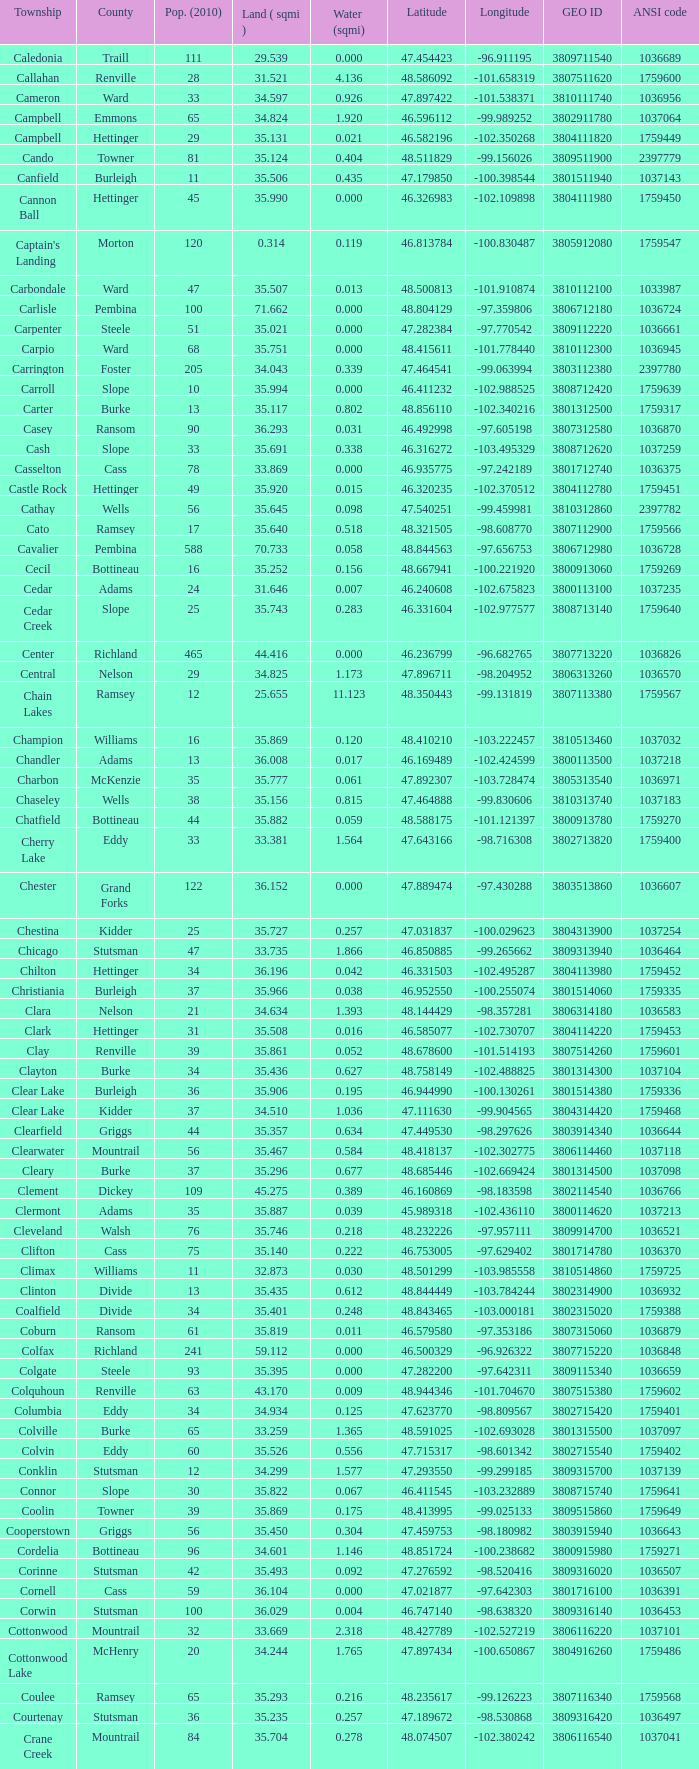What was the longitude of the township with a latitude of 48.075823? -98.857272. 